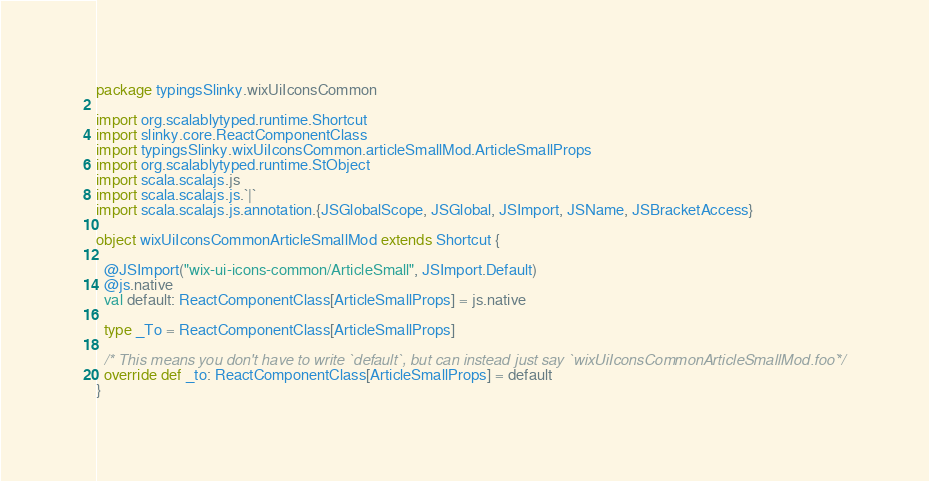<code> <loc_0><loc_0><loc_500><loc_500><_Scala_>package typingsSlinky.wixUiIconsCommon

import org.scalablytyped.runtime.Shortcut
import slinky.core.ReactComponentClass
import typingsSlinky.wixUiIconsCommon.articleSmallMod.ArticleSmallProps
import org.scalablytyped.runtime.StObject
import scala.scalajs.js
import scala.scalajs.js.`|`
import scala.scalajs.js.annotation.{JSGlobalScope, JSGlobal, JSImport, JSName, JSBracketAccess}

object wixUiIconsCommonArticleSmallMod extends Shortcut {
  
  @JSImport("wix-ui-icons-common/ArticleSmall", JSImport.Default)
  @js.native
  val default: ReactComponentClass[ArticleSmallProps] = js.native
  
  type _To = ReactComponentClass[ArticleSmallProps]
  
  /* This means you don't have to write `default`, but can instead just say `wixUiIconsCommonArticleSmallMod.foo` */
  override def _to: ReactComponentClass[ArticleSmallProps] = default
}
</code> 